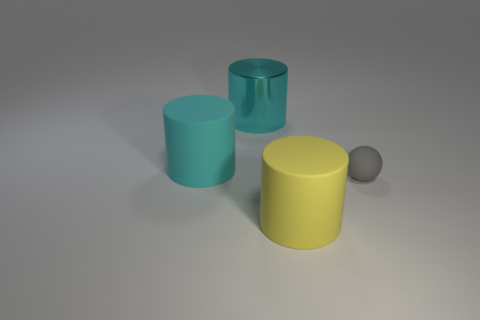Can you describe the colors of the objects in the image? Certainly! On the left, there is a cyan cylinder with a matte finish. In the center, there is a yellow cylinder with a glossy appearance. On the right, we have a cyan cylinder that seems to have a metallic sheen, and lastly, there's a small gray sphere. 